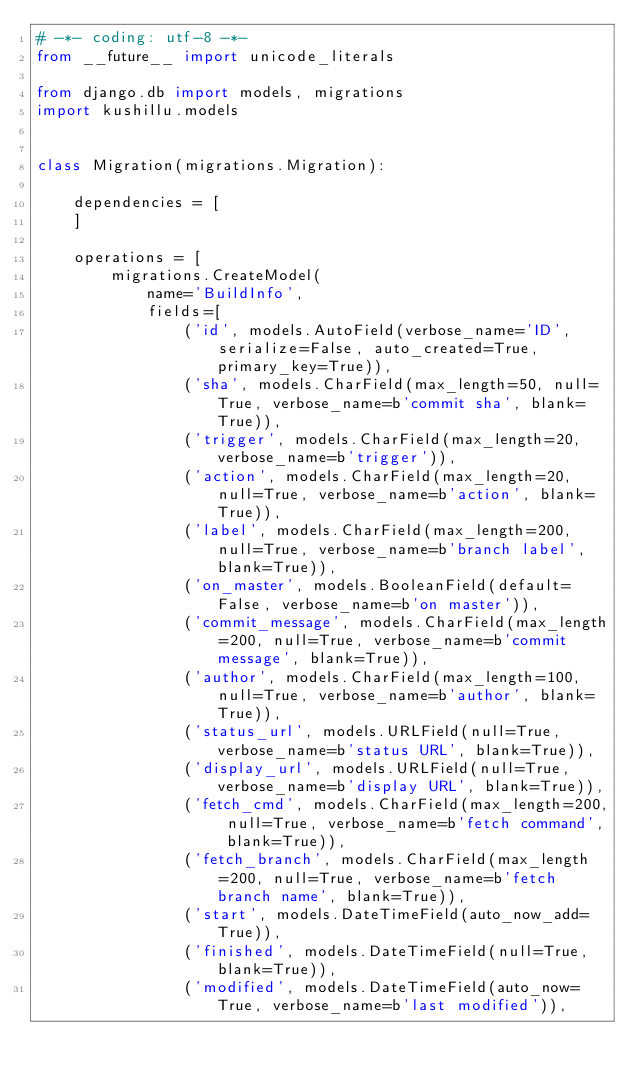<code> <loc_0><loc_0><loc_500><loc_500><_Python_># -*- coding: utf-8 -*-
from __future__ import unicode_literals

from django.db import models, migrations
import kushillu.models


class Migration(migrations.Migration):

    dependencies = [
    ]

    operations = [
        migrations.CreateModel(
            name='BuildInfo',
            fields=[
                ('id', models.AutoField(verbose_name='ID', serialize=False, auto_created=True, primary_key=True)),
                ('sha', models.CharField(max_length=50, null=True, verbose_name=b'commit sha', blank=True)),
                ('trigger', models.CharField(max_length=20, verbose_name=b'trigger')),
                ('action', models.CharField(max_length=20, null=True, verbose_name=b'action', blank=True)),
                ('label', models.CharField(max_length=200, null=True, verbose_name=b'branch label', blank=True)),
                ('on_master', models.BooleanField(default=False, verbose_name=b'on master')),
                ('commit_message', models.CharField(max_length=200, null=True, verbose_name=b'commit message', blank=True)),
                ('author', models.CharField(max_length=100, null=True, verbose_name=b'author', blank=True)),
                ('status_url', models.URLField(null=True, verbose_name=b'status URL', blank=True)),
                ('display_url', models.URLField(null=True, verbose_name=b'display URL', blank=True)),
                ('fetch_cmd', models.CharField(max_length=200, null=True, verbose_name=b'fetch command', blank=True)),
                ('fetch_branch', models.CharField(max_length=200, null=True, verbose_name=b'fetch branch name', blank=True)),
                ('start', models.DateTimeField(auto_now_add=True)),
                ('finished', models.DateTimeField(null=True, blank=True)),
                ('modified', models.DateTimeField(auto_now=True, verbose_name=b'last modified')),</code> 